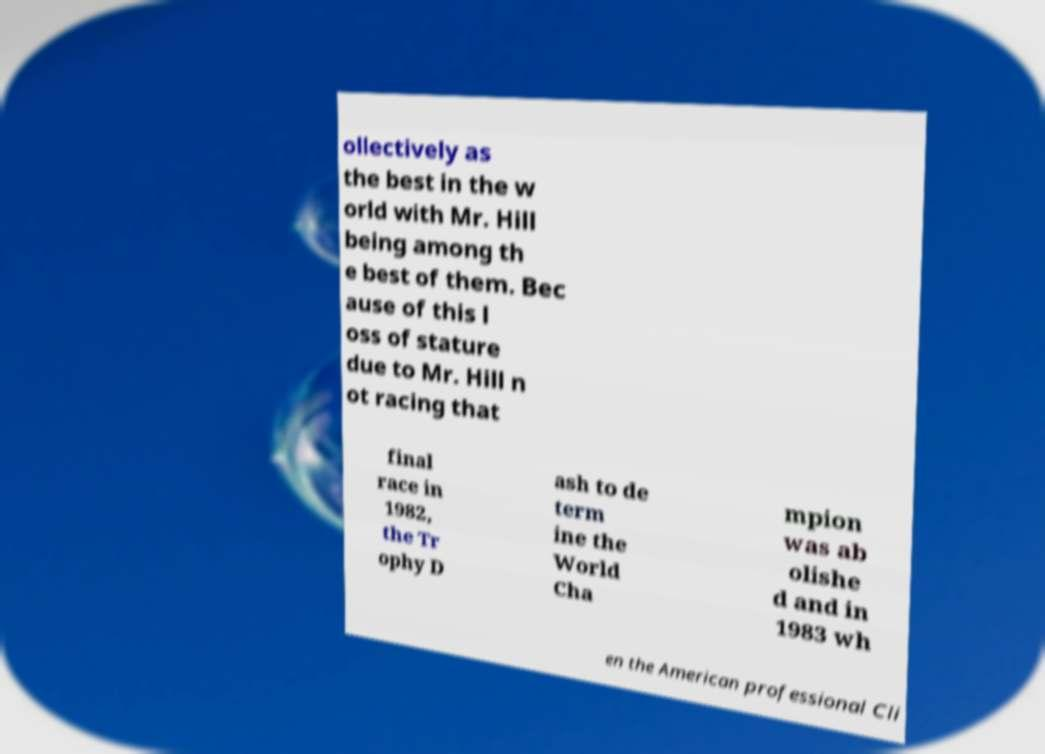Please identify and transcribe the text found in this image. ollectively as the best in the w orld with Mr. Hill being among th e best of them. Bec ause of this l oss of stature due to Mr. Hill n ot racing that final race in 1982, the Tr ophy D ash to de term ine the World Cha mpion was ab olishe d and in 1983 wh en the American professional Cli 